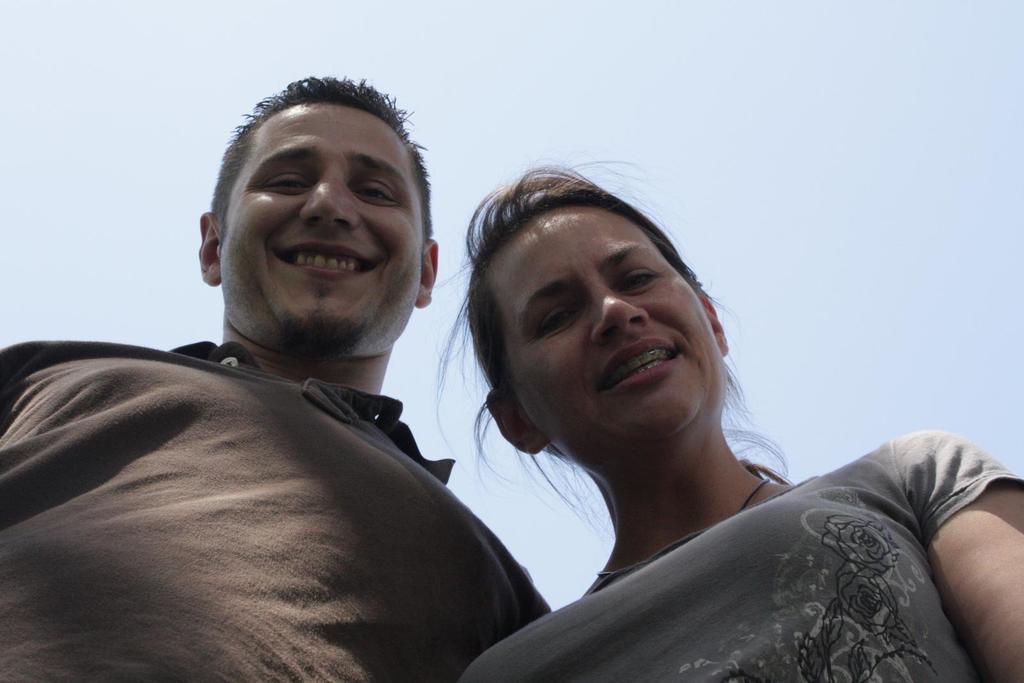In one or two sentences, can you explain what this image depicts? In this picture we can see a man and a woman smiling. 